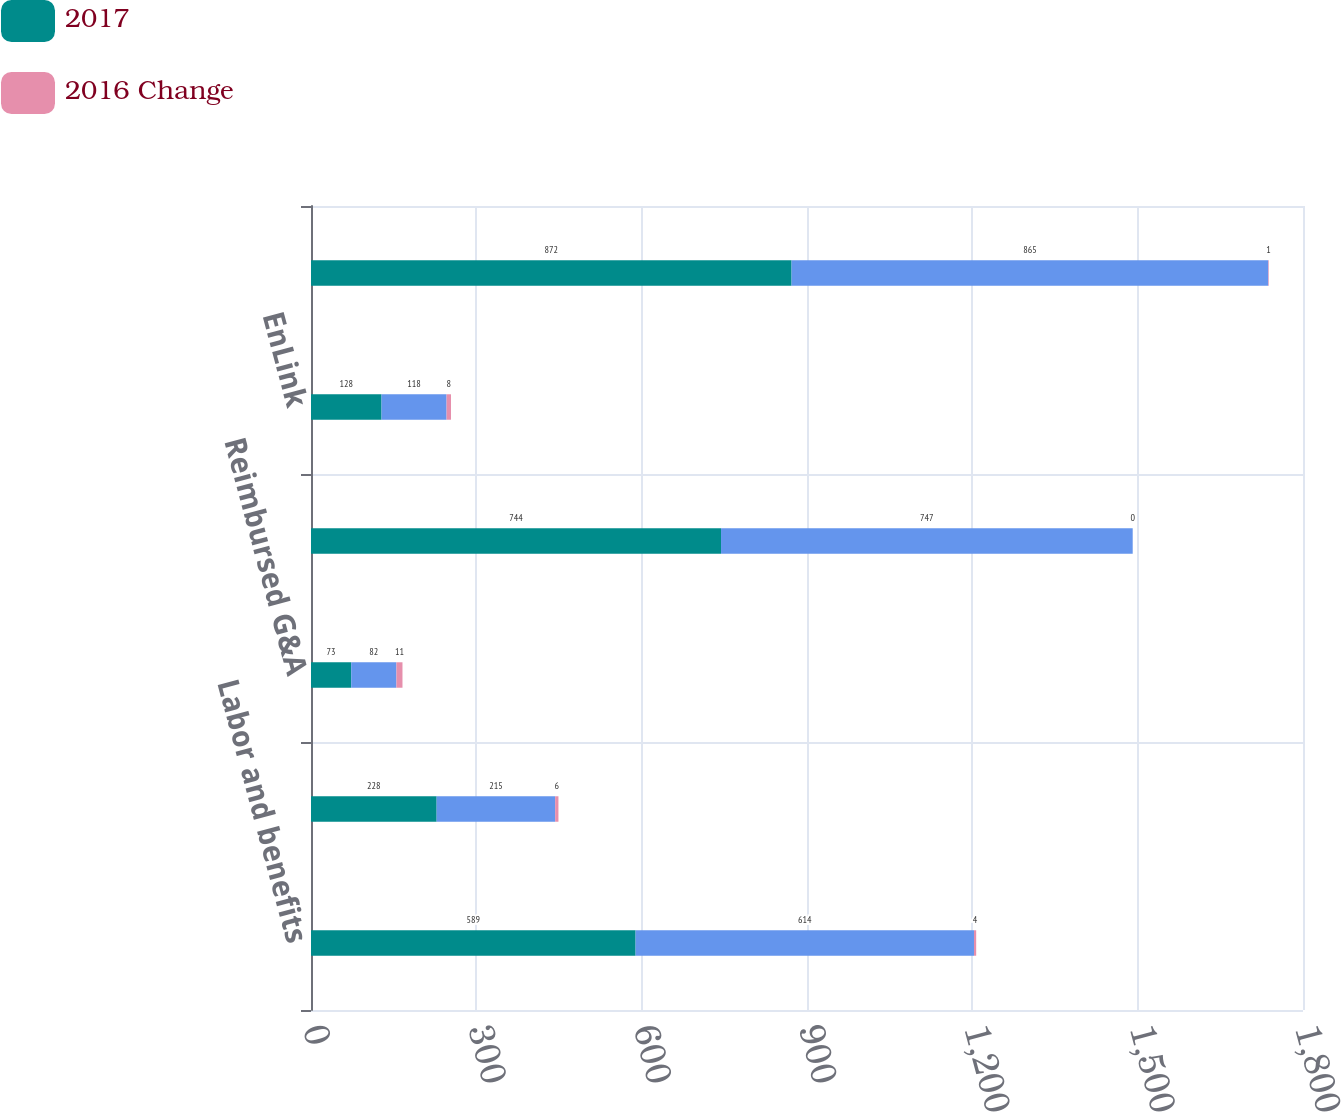Convert chart to OTSL. <chart><loc_0><loc_0><loc_500><loc_500><stacked_bar_chart><ecel><fcel>Labor and benefits<fcel>Non-labor<fcel>Reimbursed G&A<fcel>Total Devon<fcel>EnLink<fcel>Total<nl><fcel>2017<fcel>589<fcel>228<fcel>73<fcel>744<fcel>128<fcel>872<nl><fcel>nan<fcel>614<fcel>215<fcel>82<fcel>747<fcel>118<fcel>865<nl><fcel>2016 Change<fcel>4<fcel>6<fcel>11<fcel>0<fcel>8<fcel>1<nl></chart> 